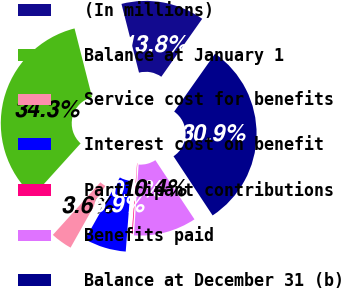Convert chart to OTSL. <chart><loc_0><loc_0><loc_500><loc_500><pie_chart><fcel>(In millions)<fcel>Balance at January 1<fcel>Service cost for benefits<fcel>Interest cost on benefit<fcel>Participant contributions<fcel>Benefits paid<fcel>Balance at December 31 (b)<nl><fcel>13.76%<fcel>34.32%<fcel>3.55%<fcel>6.95%<fcel>0.14%<fcel>10.36%<fcel>30.92%<nl></chart> 